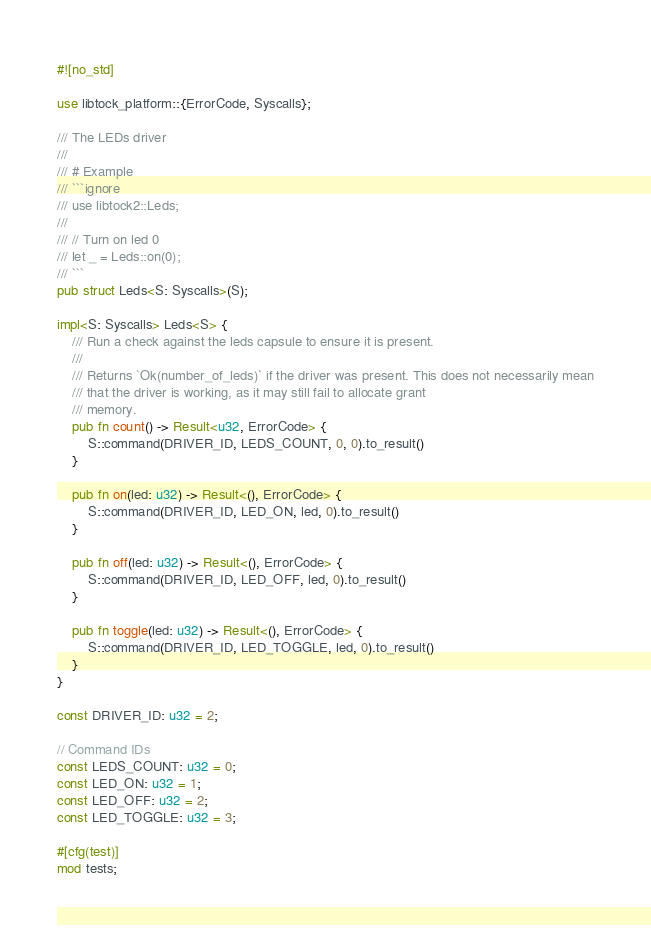Convert code to text. <code><loc_0><loc_0><loc_500><loc_500><_Rust_>#![no_std]

use libtock_platform::{ErrorCode, Syscalls};

/// The LEDs driver
///
/// # Example
/// ```ignore
/// use libtock2::Leds;
///
/// // Turn on led 0
/// let _ = Leds::on(0);
/// ```
pub struct Leds<S: Syscalls>(S);

impl<S: Syscalls> Leds<S> {
    /// Run a check against the leds capsule to ensure it is present.
    ///
    /// Returns `Ok(number_of_leds)` if the driver was present. This does not necessarily mean
    /// that the driver is working, as it may still fail to allocate grant
    /// memory.
    pub fn count() -> Result<u32, ErrorCode> {
        S::command(DRIVER_ID, LEDS_COUNT, 0, 0).to_result()
    }

    pub fn on(led: u32) -> Result<(), ErrorCode> {
        S::command(DRIVER_ID, LED_ON, led, 0).to_result()
    }

    pub fn off(led: u32) -> Result<(), ErrorCode> {
        S::command(DRIVER_ID, LED_OFF, led, 0).to_result()
    }

    pub fn toggle(led: u32) -> Result<(), ErrorCode> {
        S::command(DRIVER_ID, LED_TOGGLE, led, 0).to_result()
    }
}

const DRIVER_ID: u32 = 2;

// Command IDs
const LEDS_COUNT: u32 = 0;
const LED_ON: u32 = 1;
const LED_OFF: u32 = 2;
const LED_TOGGLE: u32 = 3;

#[cfg(test)]
mod tests;
</code> 